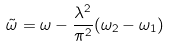<formula> <loc_0><loc_0><loc_500><loc_500>\tilde { \omega } = \omega - \frac { \lambda ^ { 2 } } { \pi ^ { 2 } } ( \omega _ { 2 } - \omega _ { 1 } )</formula> 